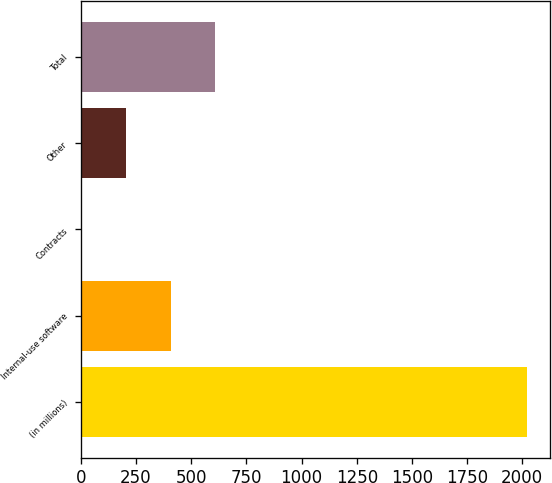Convert chart. <chart><loc_0><loc_0><loc_500><loc_500><bar_chart><fcel>(in millions)<fcel>Internal-use software<fcel>Contracts<fcel>Other<fcel>Total<nl><fcel>2023<fcel>407.8<fcel>4<fcel>205.9<fcel>609.7<nl></chart> 